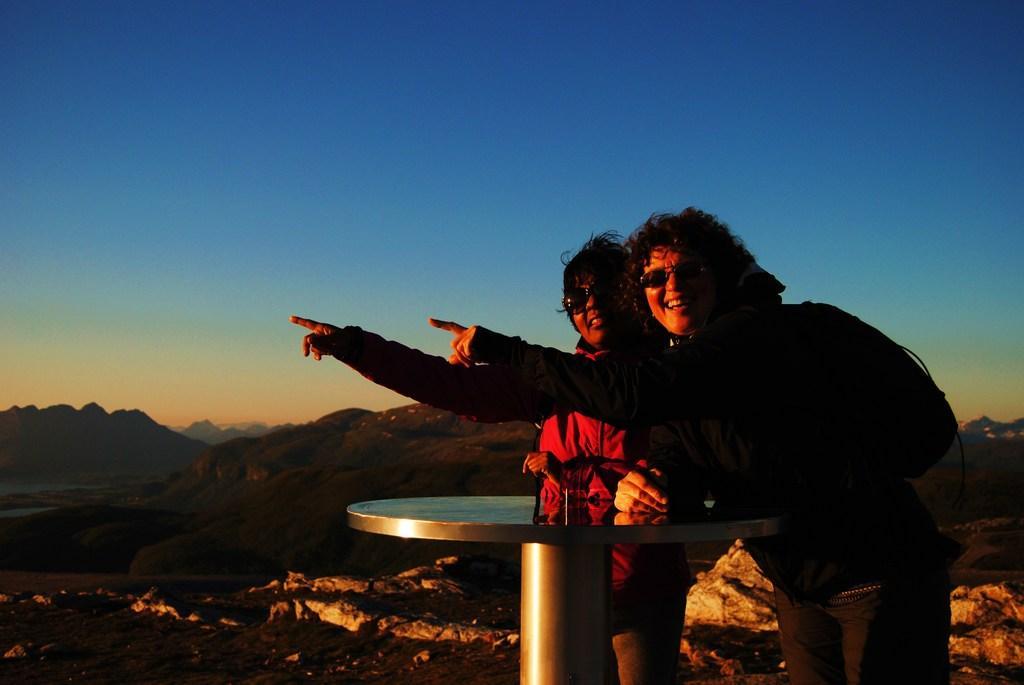Could you give a brief overview of what you see in this image? The man in black jacket is wearing goggles. He is putting one of his hands on the table. Beside him, the woman in the red jacket is pointing her fingers towards something. Both of them are smiling. In front of them, we see a table. Behind them, we see rocks and hills. At the top of the picture, we see the sky, which is blue in color. 